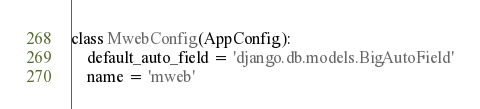<code> <loc_0><loc_0><loc_500><loc_500><_Python_>

class MwebConfig(AppConfig):
    default_auto_field = 'django.db.models.BigAutoField'
    name = 'mweb'
</code> 